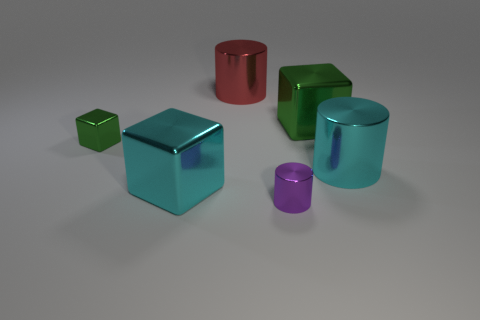What number of other objects are the same size as the red shiny cylinder?
Give a very brief answer. 3. What is the size of the object to the left of the large cyan object left of the red metal thing?
Give a very brief answer. Small. What is the color of the large shiny block left of the green metal object on the right side of the tiny object behind the big cyan cylinder?
Keep it short and to the point. Cyan. What size is the metallic cube that is both behind the cyan cube and on the left side of the big red metallic cylinder?
Keep it short and to the point. Small. How many other objects are there of the same shape as the purple object?
Your answer should be very brief. 2. How many cubes are either large cyan things or purple objects?
Your answer should be compact. 1. There is a shiny thing that is on the left side of the big cyan thing that is left of the big red cylinder; are there any metal cylinders in front of it?
Ensure brevity in your answer.  Yes. The small metallic thing that is the same shape as the large red object is what color?
Ensure brevity in your answer.  Purple. What number of brown objects are either big blocks or big metallic things?
Your answer should be compact. 0. Do the large red shiny object and the purple object have the same shape?
Ensure brevity in your answer.  Yes. 